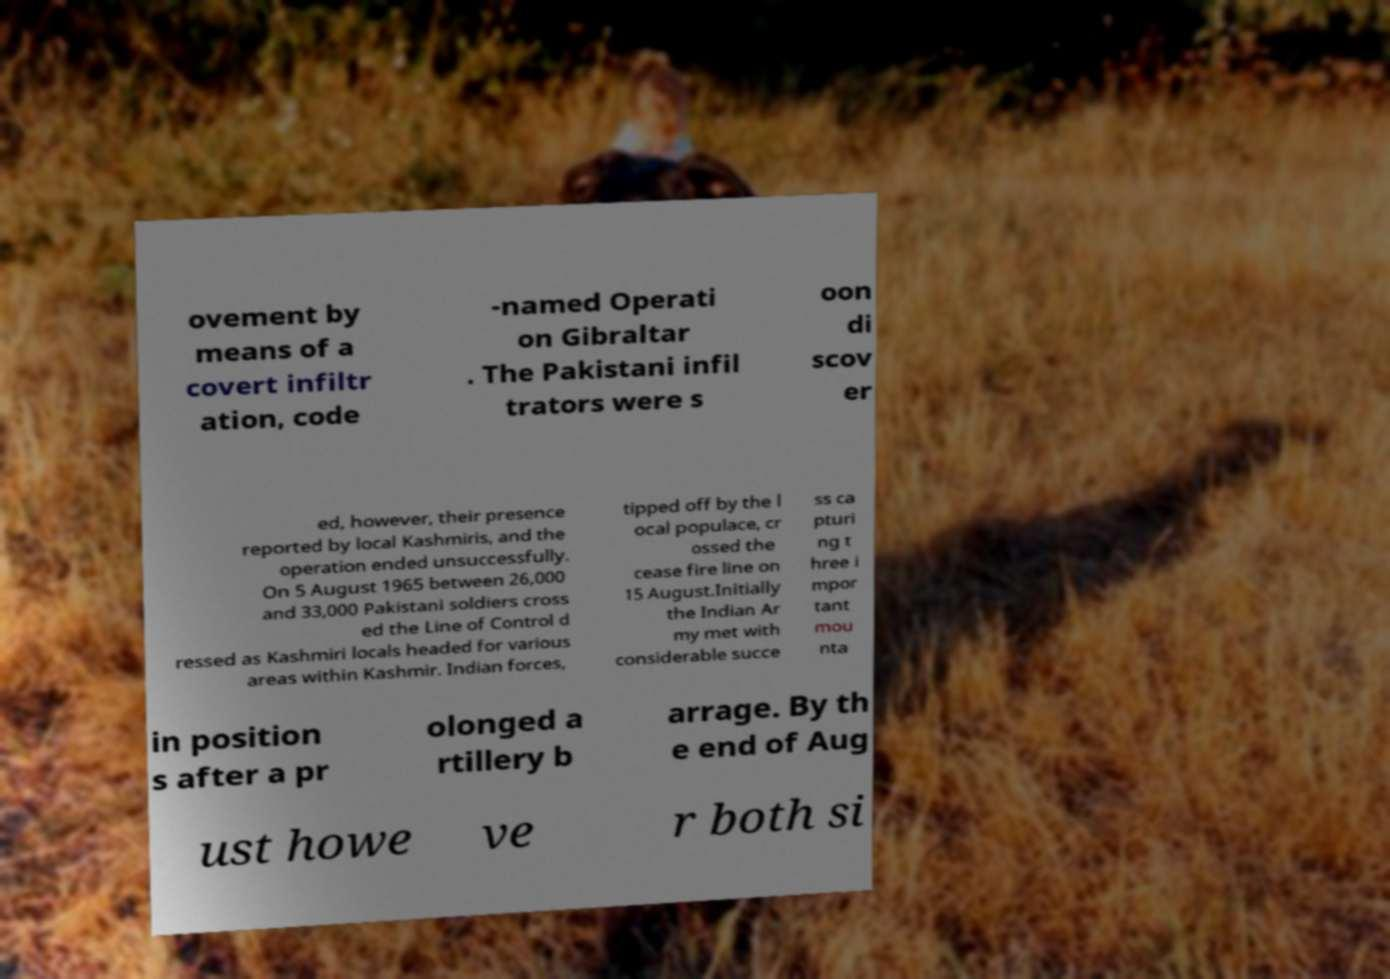Can you read and provide the text displayed in the image?This photo seems to have some interesting text. Can you extract and type it out for me? ovement by means of a covert infiltr ation, code -named Operati on Gibraltar . The Pakistani infil trators were s oon di scov er ed, however, their presence reported by local Kashmiris, and the operation ended unsuccessfully. On 5 August 1965 between 26,000 and 33,000 Pakistani soldiers cross ed the Line of Control d ressed as Kashmiri locals headed for various areas within Kashmir. Indian forces, tipped off by the l ocal populace, cr ossed the cease fire line on 15 August.Initially the Indian Ar my met with considerable succe ss ca pturi ng t hree i mpor tant mou nta in position s after a pr olonged a rtillery b arrage. By th e end of Aug ust howe ve r both si 